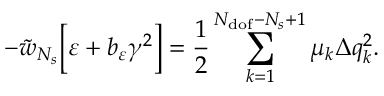Convert formula to latex. <formula><loc_0><loc_0><loc_500><loc_500>- \tilde { w } _ { N _ { s } } \left [ \varepsilon + b _ { \varepsilon } \gamma ^ { 2 } \right ] = \frac { 1 } { 2 } \sum _ { k = 1 } ^ { N _ { d o f } - N _ { s } + 1 } { \mu _ { k } \Delta q _ { k } ^ { 2 } } .</formula> 